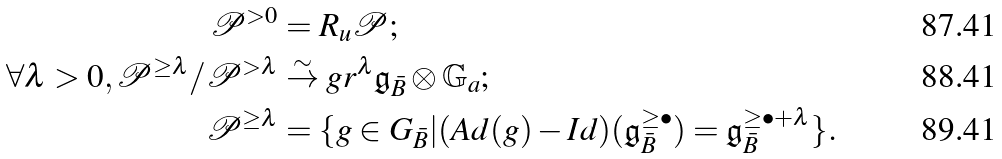<formula> <loc_0><loc_0><loc_500><loc_500>\mathcal { P } ^ { > 0 } & = R _ { u } \mathcal { P } ; \\ \forall \lambda > 0 , \mathcal { P } ^ { \geq \lambda } / \mathcal { P } ^ { > \lambda } & \stackrel { \sim } { \rightarrow } g r ^ { \lambda } \mathfrak { g } _ { \bar { B } } \otimes \mathbb { G } _ { a } ; \\ \mathcal { P } ^ { \geq \lambda } & = \{ g \in G _ { \bar { B } } | ( A d ( g ) - I d ) ( \mathfrak { g } _ { \bar { B } } ^ { \geq \bullet } ) = \mathfrak { g } _ { \bar { B } } ^ { \geq \bullet + \lambda } \} .</formula> 